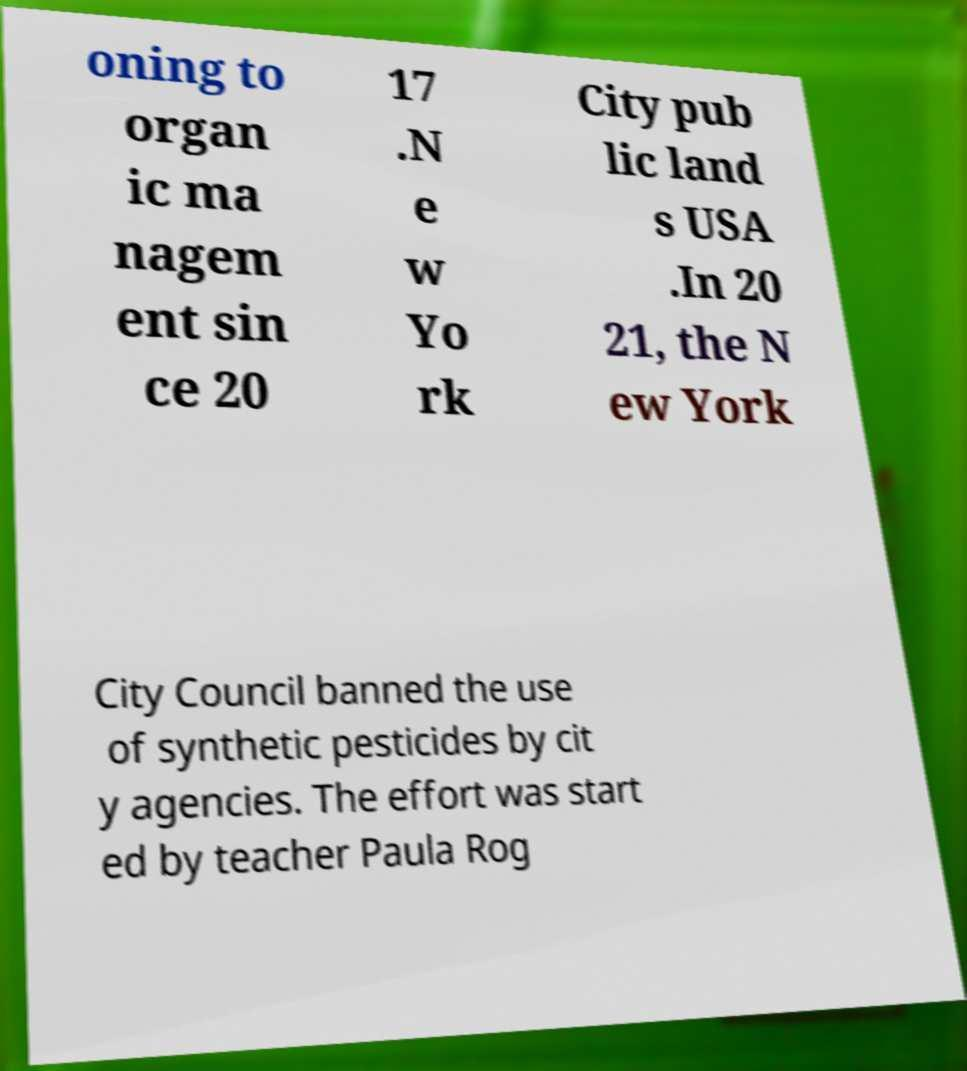What messages or text are displayed in this image? I need them in a readable, typed format. oning to organ ic ma nagem ent sin ce 20 17 .N e w Yo rk City pub lic land s USA .In 20 21, the N ew York City Council banned the use of synthetic pesticides by cit y agencies. The effort was start ed by teacher Paula Rog 